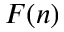<formula> <loc_0><loc_0><loc_500><loc_500>F ( n )</formula> 